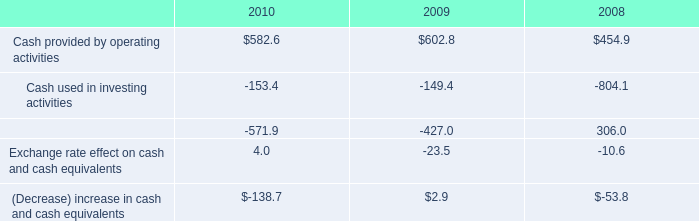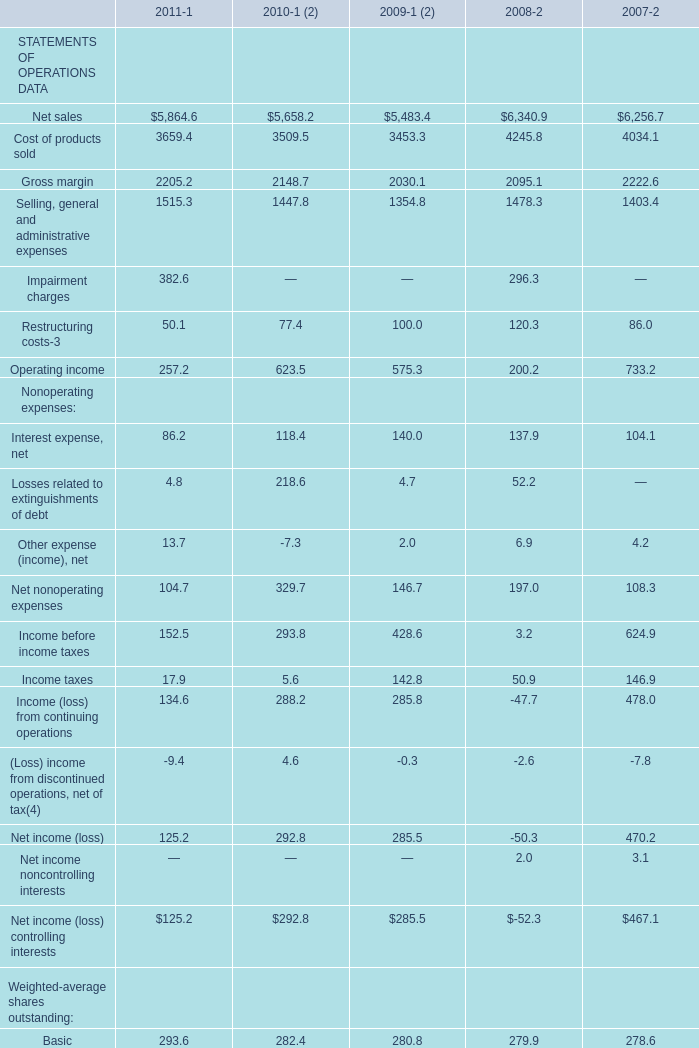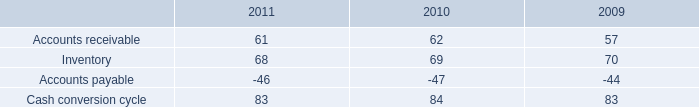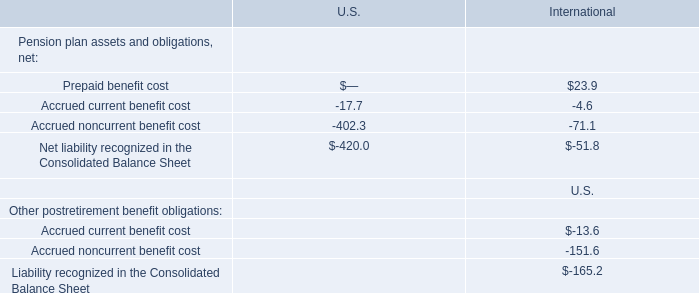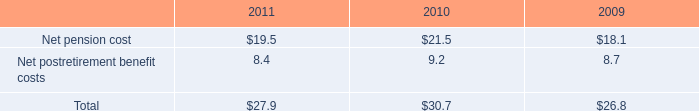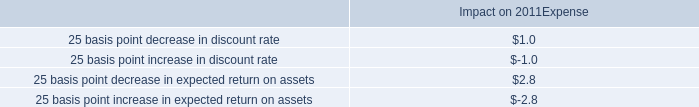What was the total amount of Weighted-average shares outstanding in 2011? 
Computations: (293.6 + 296.2)
Answer: 589.8. 